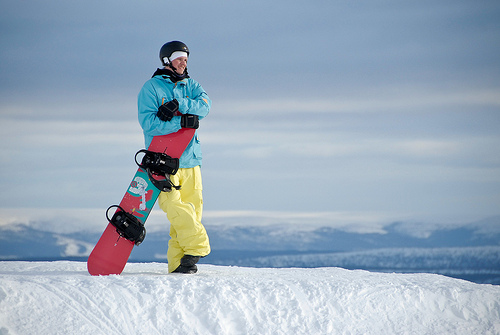What is the person in the image doing? The person is standing on a snow-covered slope with a snowboard, possibly taking a break or preparing to snowboard down the slope. 